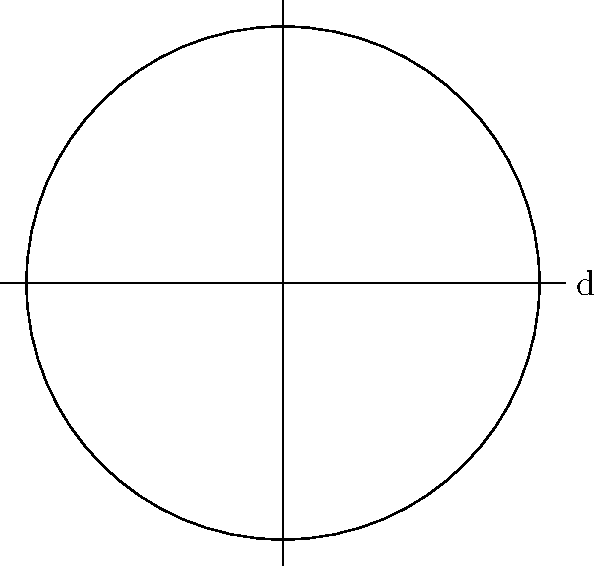As part of your off-season culinary training, you're learning about kitchen equipment. You have a spherical mixing bowl with a diameter of 12 inches. What is the surface area of this bowl in square inches? (Use $\pi = 3.14$ and round your answer to the nearest whole number.) Let's approach this step-by-step:

1) The formula for the surface area of a sphere is $A = 4\pi r^2$, where $r$ is the radius.

2) We're given the diameter (d) of 12 inches. The radius is half of the diameter:
   $r = \frac{d}{2} = \frac{12}{2} = 6$ inches

3) Now, let's substitute this into our formula:
   $A = 4\pi r^2$
   $A = 4 \cdot 3.14 \cdot 6^2$

4) Let's calculate:
   $A = 4 \cdot 3.14 \cdot 36$
   $A = 452.16$ square inches

5) Rounding to the nearest whole number:
   $A \approx 452$ square inches
Answer: 452 square inches 